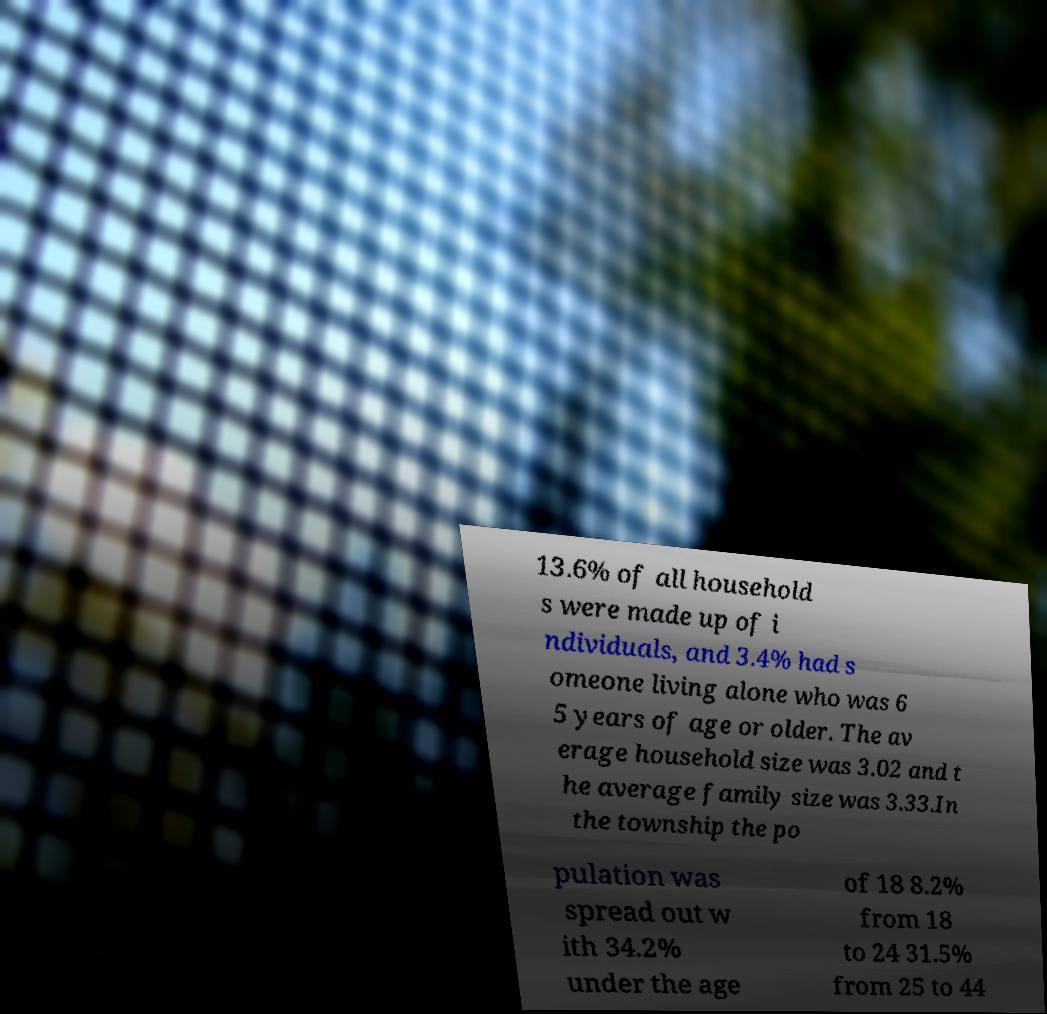Please read and relay the text visible in this image. What does it say? 13.6% of all household s were made up of i ndividuals, and 3.4% had s omeone living alone who was 6 5 years of age or older. The av erage household size was 3.02 and t he average family size was 3.33.In the township the po pulation was spread out w ith 34.2% under the age of 18 8.2% from 18 to 24 31.5% from 25 to 44 